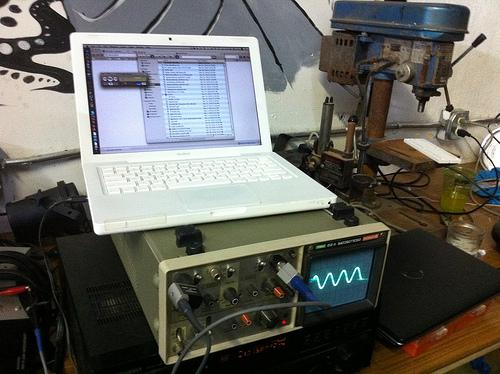Question: what is the desk made out of?
Choices:
A. Glass.
B. Wood.
C. Plastic.
D. Metal.
Answer with the letter. Answer: B Question: where is the scene taking place?
Choices:
A. In a shop.
B. In an office.
C. In a theater.
D. In a hospital.
Answer with the letter. Answer: A 